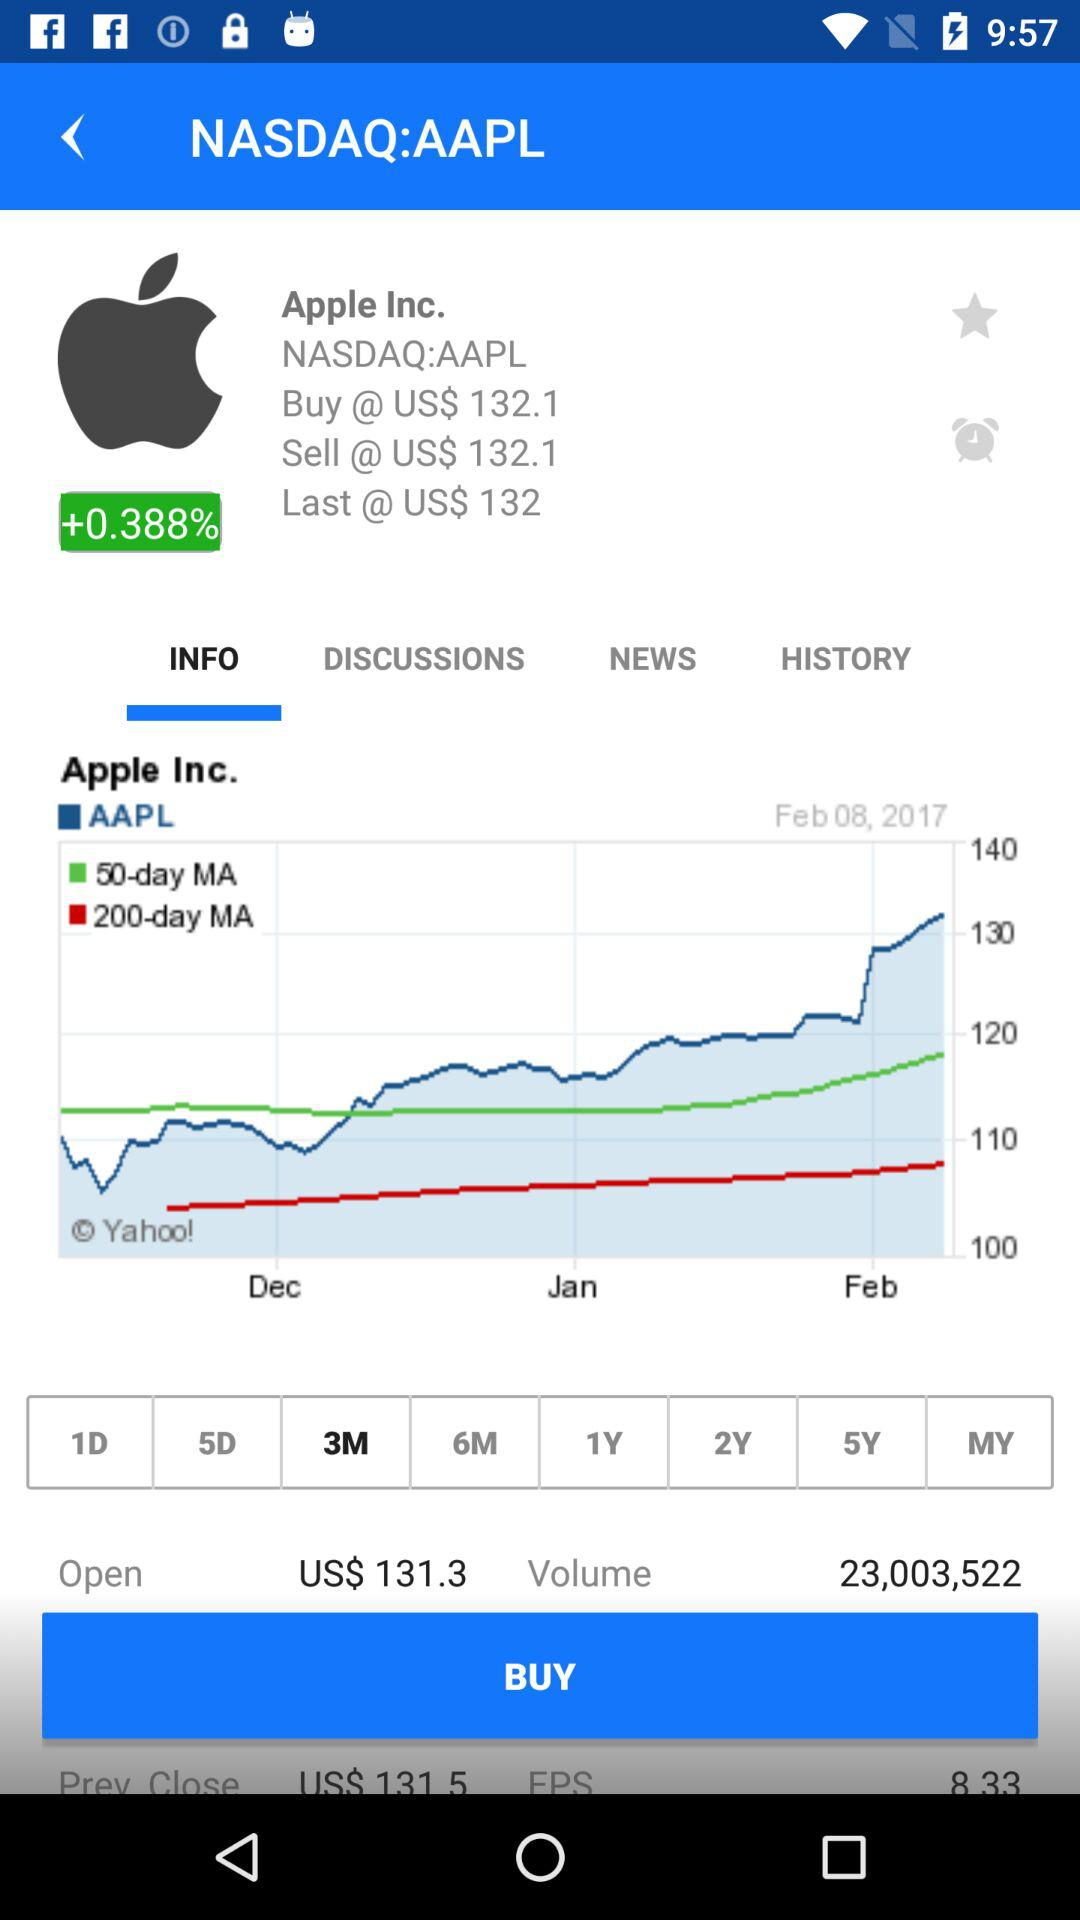What month has been selected? The month that has been selected is "3M". 